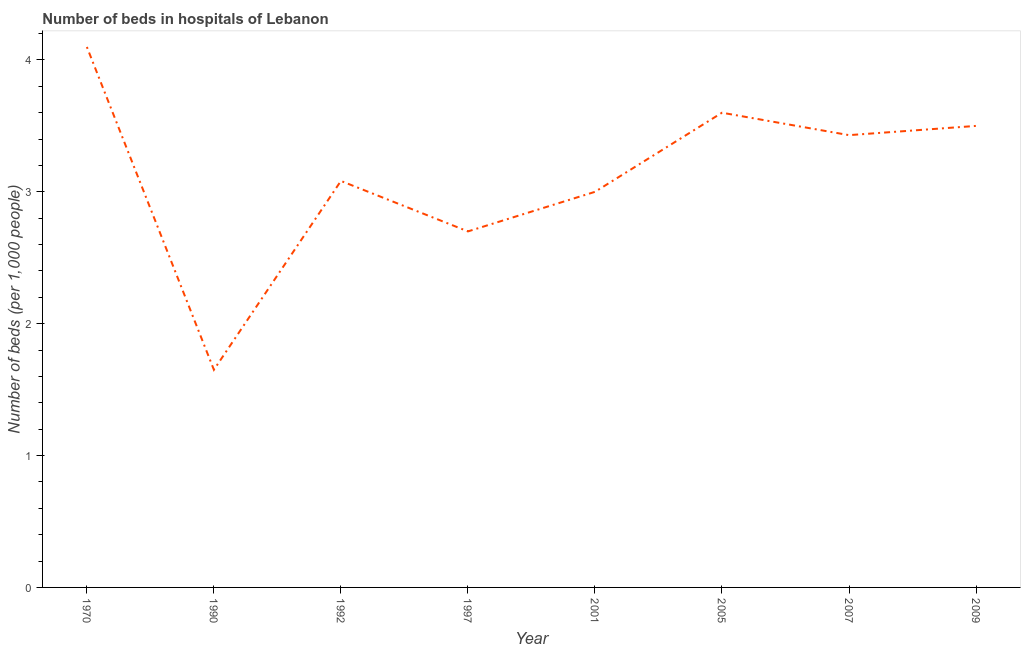Across all years, what is the maximum number of hospital beds?
Offer a very short reply. 4.1. Across all years, what is the minimum number of hospital beds?
Keep it short and to the point. 1.65. What is the sum of the number of hospital beds?
Make the answer very short. 25.06. What is the difference between the number of hospital beds in 2001 and 2009?
Ensure brevity in your answer.  -0.5. What is the average number of hospital beds per year?
Offer a terse response. 3.13. What is the median number of hospital beds?
Offer a terse response. 3.26. In how many years, is the number of hospital beds greater than 3.2 %?
Your answer should be compact. 4. What is the ratio of the number of hospital beds in 1992 to that in 2005?
Give a very brief answer. 0.86. Is the number of hospital beds in 1990 less than that in 2007?
Make the answer very short. Yes. What is the difference between the highest and the second highest number of hospital beds?
Keep it short and to the point. 0.5. Is the sum of the number of hospital beds in 1970 and 2001 greater than the maximum number of hospital beds across all years?
Offer a very short reply. Yes. What is the difference between the highest and the lowest number of hospital beds?
Give a very brief answer. 2.45. How many lines are there?
Your response must be concise. 1. What is the difference between two consecutive major ticks on the Y-axis?
Provide a short and direct response. 1. Are the values on the major ticks of Y-axis written in scientific E-notation?
Offer a terse response. No. What is the title of the graph?
Offer a very short reply. Number of beds in hospitals of Lebanon. What is the label or title of the Y-axis?
Provide a succinct answer. Number of beds (per 1,0 people). What is the Number of beds (per 1,000 people) in 1970?
Your response must be concise. 4.1. What is the Number of beds (per 1,000 people) of 1990?
Keep it short and to the point. 1.65. What is the Number of beds (per 1,000 people) of 1992?
Your answer should be compact. 3.08. What is the Number of beds (per 1,000 people) of 1997?
Offer a terse response. 2.7. What is the Number of beds (per 1,000 people) of 2001?
Provide a succinct answer. 3. What is the Number of beds (per 1,000 people) in 2007?
Give a very brief answer. 3.43. What is the difference between the Number of beds (per 1,000 people) in 1970 and 1990?
Keep it short and to the point. 2.45. What is the difference between the Number of beds (per 1,000 people) in 1970 and 1997?
Your response must be concise. 1.4. What is the difference between the Number of beds (per 1,000 people) in 1970 and 2001?
Make the answer very short. 1.1. What is the difference between the Number of beds (per 1,000 people) in 1970 and 2005?
Offer a very short reply. 0.5. What is the difference between the Number of beds (per 1,000 people) in 1970 and 2007?
Keep it short and to the point. 0.67. What is the difference between the Number of beds (per 1,000 people) in 1970 and 2009?
Offer a terse response. 0.6. What is the difference between the Number of beds (per 1,000 people) in 1990 and 1992?
Keep it short and to the point. -1.43. What is the difference between the Number of beds (per 1,000 people) in 1990 and 1997?
Provide a short and direct response. -1.05. What is the difference between the Number of beds (per 1,000 people) in 1990 and 2001?
Provide a succinct answer. -1.35. What is the difference between the Number of beds (per 1,000 people) in 1990 and 2005?
Make the answer very short. -1.95. What is the difference between the Number of beds (per 1,000 people) in 1990 and 2007?
Make the answer very short. -1.78. What is the difference between the Number of beds (per 1,000 people) in 1990 and 2009?
Offer a very short reply. -1.85. What is the difference between the Number of beds (per 1,000 people) in 1992 and 1997?
Provide a short and direct response. 0.38. What is the difference between the Number of beds (per 1,000 people) in 1992 and 2001?
Keep it short and to the point. 0.08. What is the difference between the Number of beds (per 1,000 people) in 1992 and 2005?
Your answer should be very brief. -0.52. What is the difference between the Number of beds (per 1,000 people) in 1992 and 2007?
Offer a very short reply. -0.35. What is the difference between the Number of beds (per 1,000 people) in 1992 and 2009?
Your answer should be compact. -0.42. What is the difference between the Number of beds (per 1,000 people) in 1997 and 2007?
Your answer should be compact. -0.73. What is the difference between the Number of beds (per 1,000 people) in 1997 and 2009?
Your response must be concise. -0.8. What is the difference between the Number of beds (per 1,000 people) in 2001 and 2005?
Ensure brevity in your answer.  -0.6. What is the difference between the Number of beds (per 1,000 people) in 2001 and 2007?
Your answer should be very brief. -0.43. What is the difference between the Number of beds (per 1,000 people) in 2005 and 2007?
Ensure brevity in your answer.  0.17. What is the difference between the Number of beds (per 1,000 people) in 2005 and 2009?
Your response must be concise. 0.1. What is the difference between the Number of beds (per 1,000 people) in 2007 and 2009?
Your response must be concise. -0.07. What is the ratio of the Number of beds (per 1,000 people) in 1970 to that in 1990?
Your answer should be very brief. 2.48. What is the ratio of the Number of beds (per 1,000 people) in 1970 to that in 1992?
Your answer should be very brief. 1.33. What is the ratio of the Number of beds (per 1,000 people) in 1970 to that in 1997?
Offer a very short reply. 1.52. What is the ratio of the Number of beds (per 1,000 people) in 1970 to that in 2001?
Keep it short and to the point. 1.37. What is the ratio of the Number of beds (per 1,000 people) in 1970 to that in 2005?
Make the answer very short. 1.14. What is the ratio of the Number of beds (per 1,000 people) in 1970 to that in 2007?
Offer a terse response. 1.2. What is the ratio of the Number of beds (per 1,000 people) in 1970 to that in 2009?
Make the answer very short. 1.17. What is the ratio of the Number of beds (per 1,000 people) in 1990 to that in 1992?
Offer a terse response. 0.54. What is the ratio of the Number of beds (per 1,000 people) in 1990 to that in 1997?
Provide a short and direct response. 0.61. What is the ratio of the Number of beds (per 1,000 people) in 1990 to that in 2001?
Give a very brief answer. 0.55. What is the ratio of the Number of beds (per 1,000 people) in 1990 to that in 2005?
Provide a short and direct response. 0.46. What is the ratio of the Number of beds (per 1,000 people) in 1990 to that in 2007?
Keep it short and to the point. 0.48. What is the ratio of the Number of beds (per 1,000 people) in 1990 to that in 2009?
Offer a terse response. 0.47. What is the ratio of the Number of beds (per 1,000 people) in 1992 to that in 1997?
Provide a succinct answer. 1.14. What is the ratio of the Number of beds (per 1,000 people) in 1992 to that in 2001?
Your response must be concise. 1.03. What is the ratio of the Number of beds (per 1,000 people) in 1992 to that in 2005?
Give a very brief answer. 0.86. What is the ratio of the Number of beds (per 1,000 people) in 1992 to that in 2007?
Keep it short and to the point. 0.9. What is the ratio of the Number of beds (per 1,000 people) in 1992 to that in 2009?
Give a very brief answer. 0.88. What is the ratio of the Number of beds (per 1,000 people) in 1997 to that in 2001?
Your response must be concise. 0.9. What is the ratio of the Number of beds (per 1,000 people) in 1997 to that in 2005?
Your answer should be compact. 0.75. What is the ratio of the Number of beds (per 1,000 people) in 1997 to that in 2007?
Keep it short and to the point. 0.79. What is the ratio of the Number of beds (per 1,000 people) in 1997 to that in 2009?
Your answer should be very brief. 0.77. What is the ratio of the Number of beds (per 1,000 people) in 2001 to that in 2005?
Offer a terse response. 0.83. What is the ratio of the Number of beds (per 1,000 people) in 2001 to that in 2009?
Offer a terse response. 0.86. 